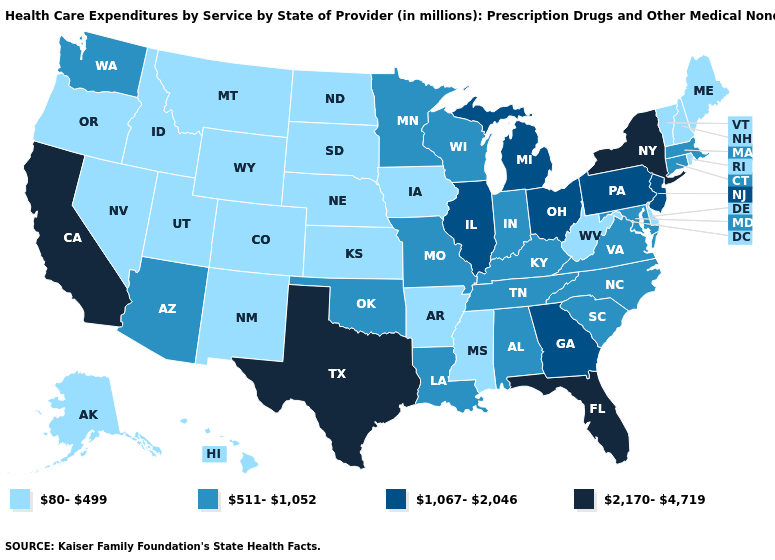Name the states that have a value in the range 1,067-2,046?
Concise answer only. Georgia, Illinois, Michigan, New Jersey, Ohio, Pennsylvania. What is the value of Arkansas?
Write a very short answer. 80-499. Does Louisiana have the lowest value in the USA?
Write a very short answer. No. Which states have the lowest value in the USA?
Quick response, please. Alaska, Arkansas, Colorado, Delaware, Hawaii, Idaho, Iowa, Kansas, Maine, Mississippi, Montana, Nebraska, Nevada, New Hampshire, New Mexico, North Dakota, Oregon, Rhode Island, South Dakota, Utah, Vermont, West Virginia, Wyoming. Which states have the highest value in the USA?
Short answer required. California, Florida, New York, Texas. Name the states that have a value in the range 1,067-2,046?
Answer briefly. Georgia, Illinois, Michigan, New Jersey, Ohio, Pennsylvania. What is the value of Michigan?
Be succinct. 1,067-2,046. Among the states that border Wisconsin , which have the highest value?
Short answer required. Illinois, Michigan. Name the states that have a value in the range 1,067-2,046?
Keep it brief. Georgia, Illinois, Michigan, New Jersey, Ohio, Pennsylvania. What is the lowest value in states that border Virginia?
Concise answer only. 80-499. Which states have the lowest value in the USA?
Give a very brief answer. Alaska, Arkansas, Colorado, Delaware, Hawaii, Idaho, Iowa, Kansas, Maine, Mississippi, Montana, Nebraska, Nevada, New Hampshire, New Mexico, North Dakota, Oregon, Rhode Island, South Dakota, Utah, Vermont, West Virginia, Wyoming. Among the states that border West Virginia , which have the lowest value?
Give a very brief answer. Kentucky, Maryland, Virginia. Does California have the highest value in the West?
Answer briefly. Yes. Name the states that have a value in the range 80-499?
Short answer required. Alaska, Arkansas, Colorado, Delaware, Hawaii, Idaho, Iowa, Kansas, Maine, Mississippi, Montana, Nebraska, Nevada, New Hampshire, New Mexico, North Dakota, Oregon, Rhode Island, South Dakota, Utah, Vermont, West Virginia, Wyoming. What is the value of California?
Answer briefly. 2,170-4,719. 